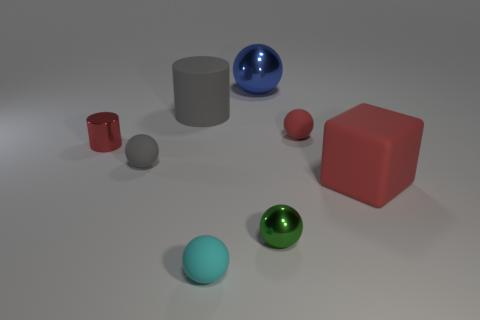Can you tell me which shapes in this image are not spheres? Certainly. There is a large red cube and two cylinders, one gray and the other smaller and metallic red. What can you tell me about the colors in this image? The image features a range of colors. There are primary colors like the red cube and blue sphere, and secondary colors like the green sphere. Neutral tones are present in the gray spheres and cylinders. 